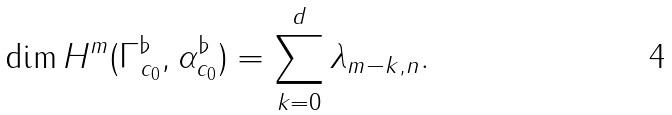Convert formula to latex. <formula><loc_0><loc_0><loc_500><loc_500>\dim H ^ { m } ( \Gamma _ { c _ { 0 } } ^ { \flat } , \alpha _ { c _ { 0 } } ^ { \flat } ) = \sum _ { k = 0 } ^ { d } \lambda _ { m - k , n } .</formula> 